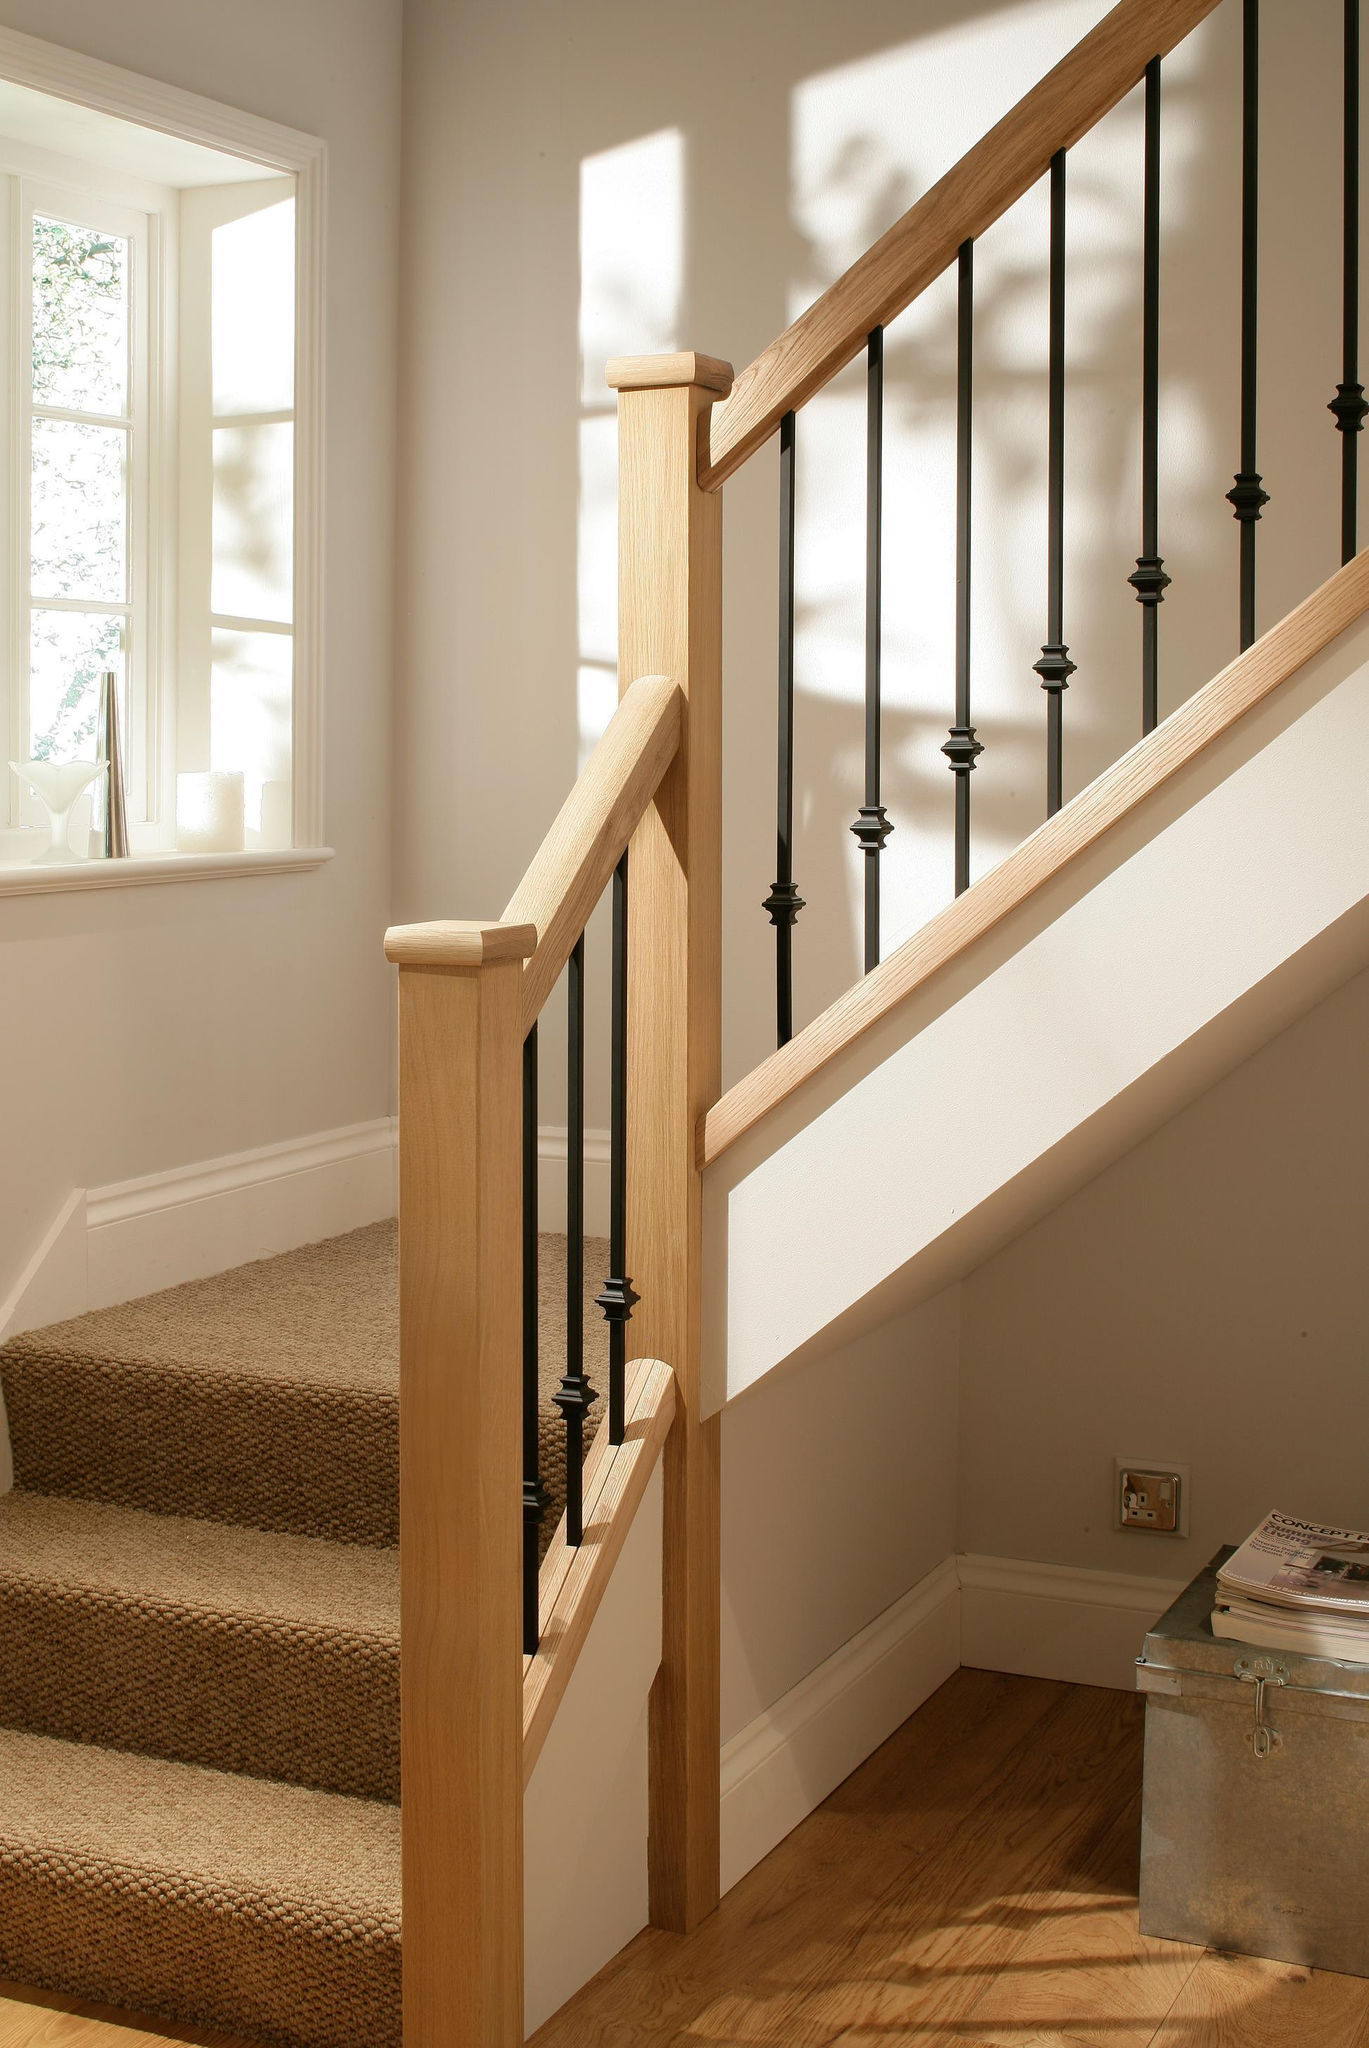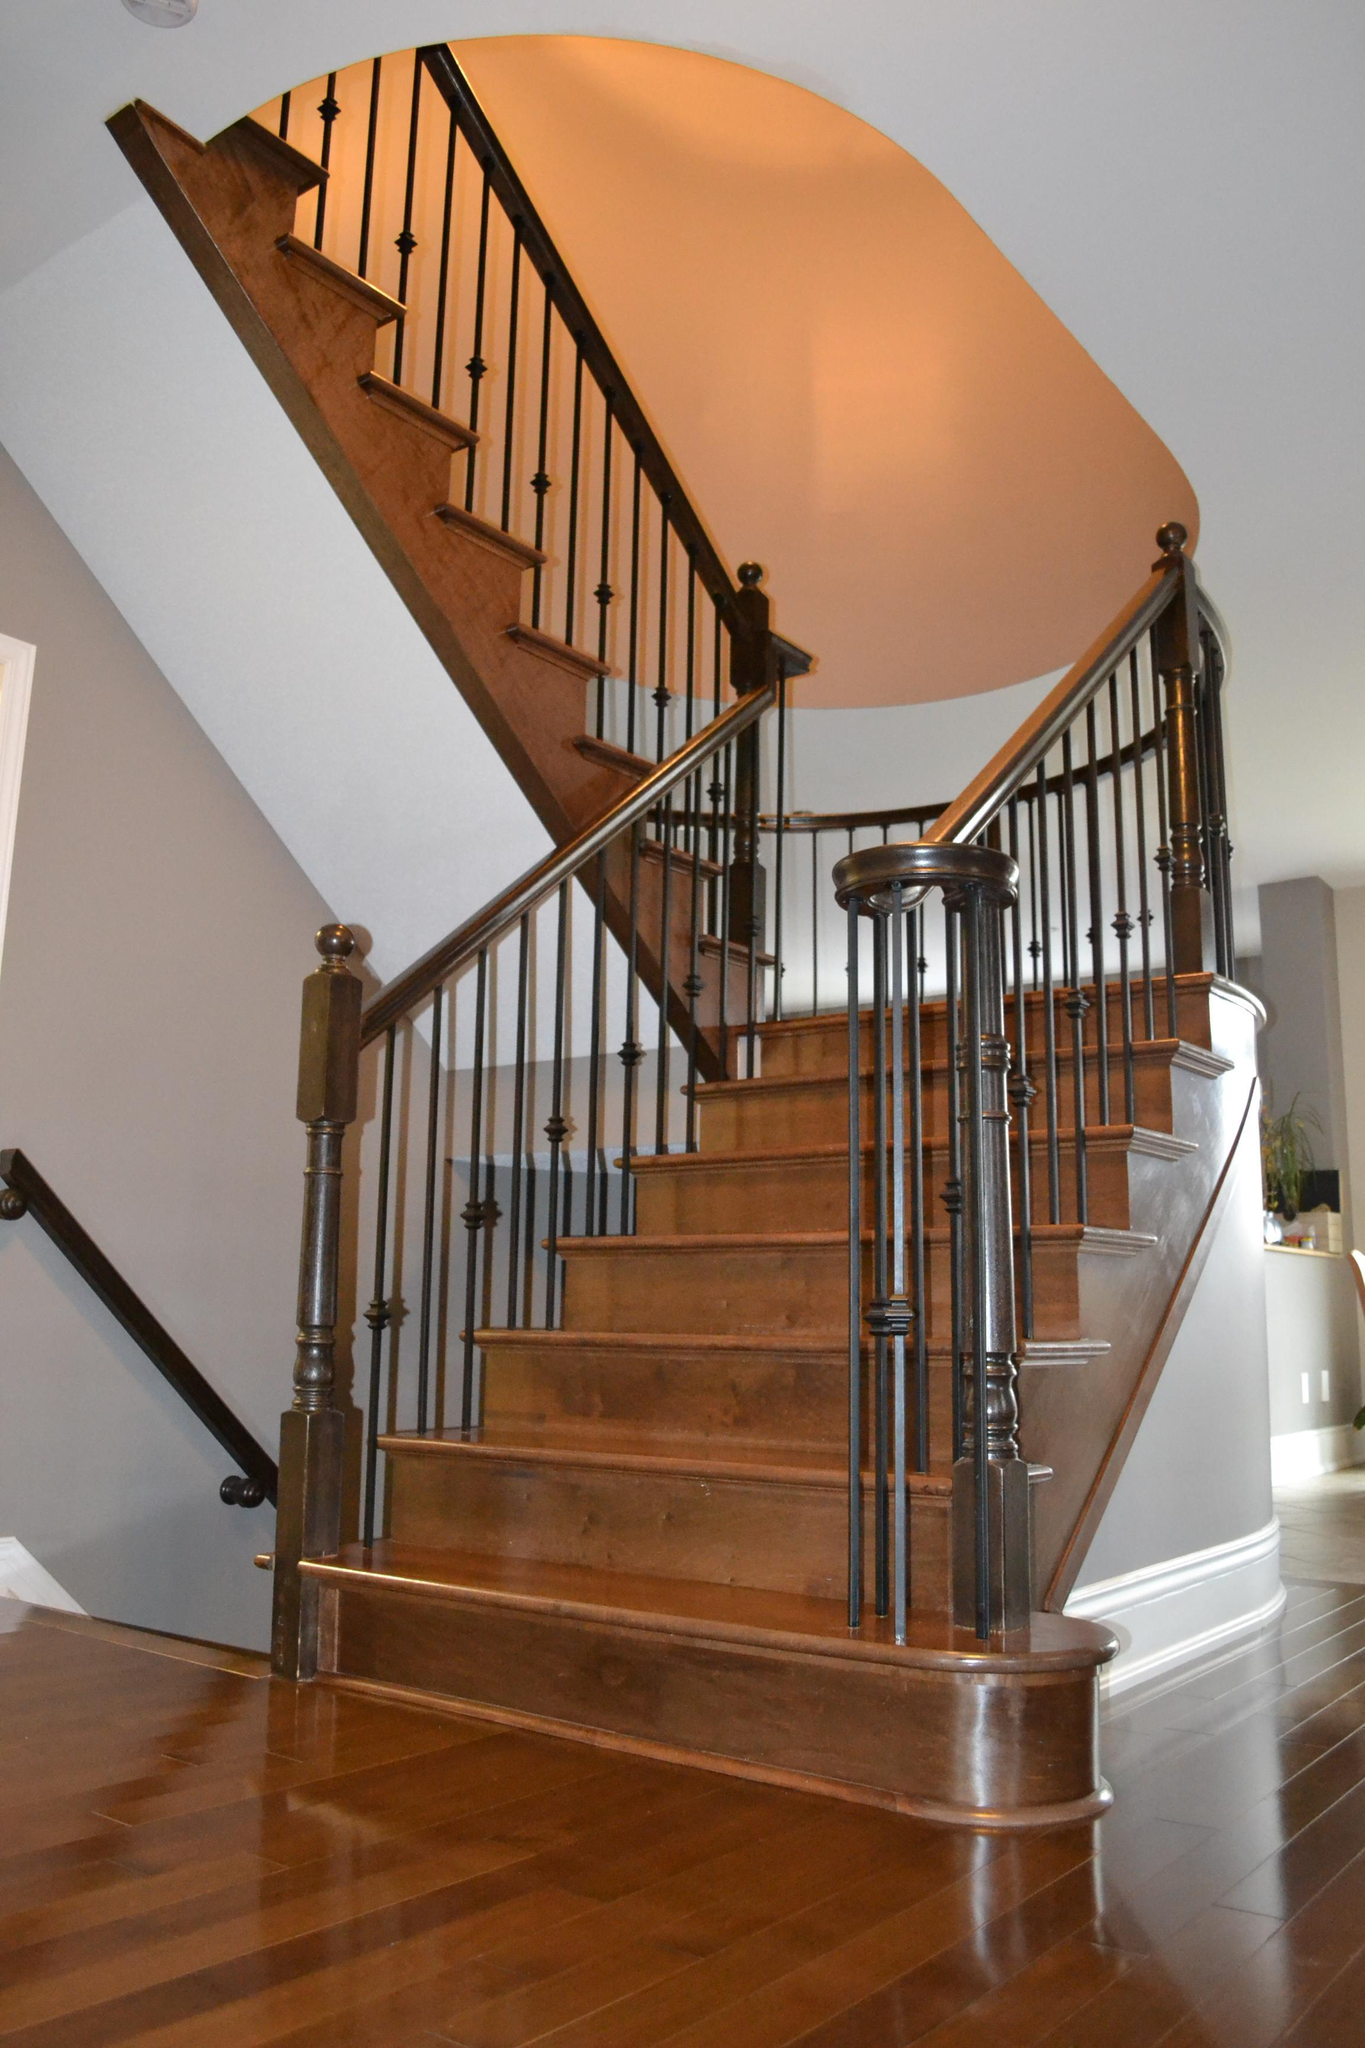The first image is the image on the left, the second image is the image on the right. Evaluate the accuracy of this statement regarding the images: "At least one stairway has white side railings.". Is it true? Answer yes or no. No. 